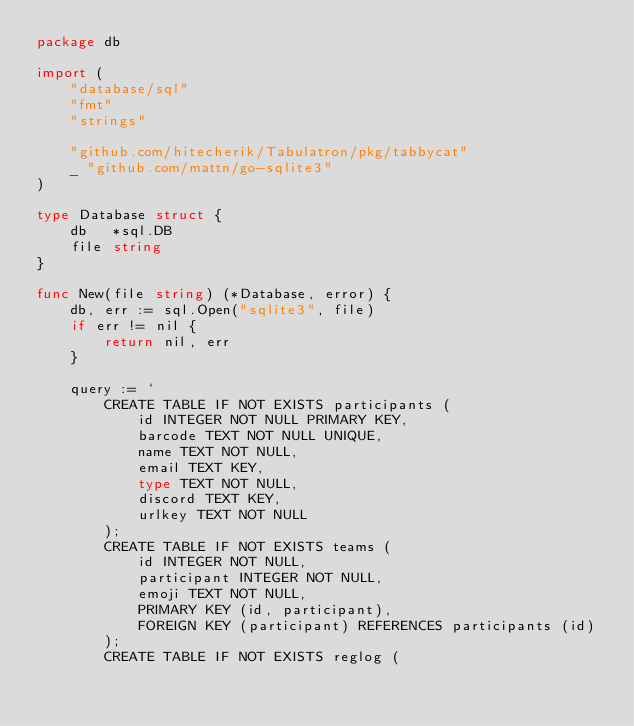Convert code to text. <code><loc_0><loc_0><loc_500><loc_500><_Go_>package db

import (
	"database/sql"
	"fmt"
	"strings"

	"github.com/hitecherik/Tabulatron/pkg/tabbycat"
	_ "github.com/mattn/go-sqlite3"
)

type Database struct {
	db   *sql.DB
	file string
}

func New(file string) (*Database, error) {
	db, err := sql.Open("sqlite3", file)
	if err != nil {
		return nil, err
	}

	query := `
		CREATE TABLE IF NOT EXISTS participants (
			id INTEGER NOT NULL PRIMARY KEY,
			barcode TEXT NOT NULL UNIQUE,
			name TEXT NOT NULL,
			email TEXT KEY,
			type TEXT NOT NULL,
			discord TEXT KEY,
			urlkey TEXT NOT NULL
		);
		CREATE TABLE IF NOT EXISTS teams (
			id INTEGER NOT NULL,
			participant INTEGER NOT NULL,
			emoji TEXT NOT NULL,
			PRIMARY KEY (id, participant),
			FOREIGN KEY (participant) REFERENCES participants (id)
		);
		CREATE TABLE IF NOT EXISTS reglog (</code> 